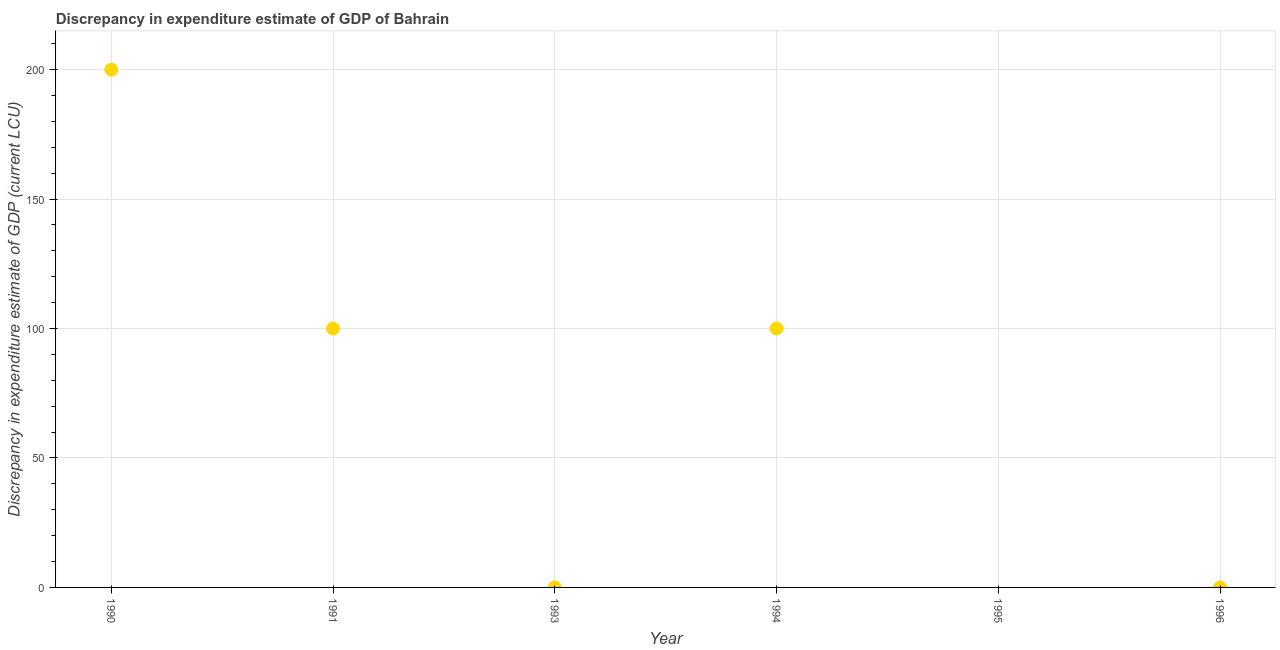Across all years, what is the maximum discrepancy in expenditure estimate of gdp?
Provide a succinct answer. 200. Across all years, what is the minimum discrepancy in expenditure estimate of gdp?
Provide a short and direct response. 0. In which year was the discrepancy in expenditure estimate of gdp maximum?
Keep it short and to the point. 1990. What is the sum of the discrepancy in expenditure estimate of gdp?
Provide a succinct answer. 400. What is the difference between the discrepancy in expenditure estimate of gdp in 1991 and 1996?
Your answer should be compact. 100. What is the average discrepancy in expenditure estimate of gdp per year?
Your answer should be compact. 66.67. What is the median discrepancy in expenditure estimate of gdp?
Offer a very short reply. 50. In how many years, is the discrepancy in expenditure estimate of gdp greater than 10 LCU?
Give a very brief answer. 3. What is the ratio of the discrepancy in expenditure estimate of gdp in 1991 to that in 1994?
Offer a very short reply. 1. What is the difference between the highest and the second highest discrepancy in expenditure estimate of gdp?
Provide a succinct answer. 100. What is the difference between the highest and the lowest discrepancy in expenditure estimate of gdp?
Offer a terse response. 200. Does the discrepancy in expenditure estimate of gdp monotonically increase over the years?
Give a very brief answer. No. How many dotlines are there?
Offer a terse response. 1. Are the values on the major ticks of Y-axis written in scientific E-notation?
Give a very brief answer. No. Does the graph contain grids?
Your answer should be compact. Yes. What is the title of the graph?
Provide a short and direct response. Discrepancy in expenditure estimate of GDP of Bahrain. What is the label or title of the Y-axis?
Keep it short and to the point. Discrepancy in expenditure estimate of GDP (current LCU). What is the Discrepancy in expenditure estimate of GDP (current LCU) in 1990?
Your answer should be very brief. 200. What is the Discrepancy in expenditure estimate of GDP (current LCU) in 1991?
Your response must be concise. 100. What is the Discrepancy in expenditure estimate of GDP (current LCU) in 1993?
Your response must be concise. 0. What is the Discrepancy in expenditure estimate of GDP (current LCU) in 1995?
Give a very brief answer. 0. What is the Discrepancy in expenditure estimate of GDP (current LCU) in 1996?
Offer a very short reply. 6e-8. What is the difference between the Discrepancy in expenditure estimate of GDP (current LCU) in 1990 and 1994?
Your answer should be compact. 100. What is the difference between the Discrepancy in expenditure estimate of GDP (current LCU) in 1990 and 1996?
Your response must be concise. 200. What is the difference between the Discrepancy in expenditure estimate of GDP (current LCU) in 1991 and 1994?
Offer a very short reply. 0. What is the difference between the Discrepancy in expenditure estimate of GDP (current LCU) in 1994 and 1996?
Your answer should be very brief. 100. What is the ratio of the Discrepancy in expenditure estimate of GDP (current LCU) in 1990 to that in 1991?
Give a very brief answer. 2. What is the ratio of the Discrepancy in expenditure estimate of GDP (current LCU) in 1990 to that in 1994?
Provide a short and direct response. 2. What is the ratio of the Discrepancy in expenditure estimate of GDP (current LCU) in 1990 to that in 1996?
Ensure brevity in your answer.  3.33e+09. What is the ratio of the Discrepancy in expenditure estimate of GDP (current LCU) in 1991 to that in 1996?
Offer a very short reply. 1.67e+09. What is the ratio of the Discrepancy in expenditure estimate of GDP (current LCU) in 1994 to that in 1996?
Make the answer very short. 1.67e+09. 